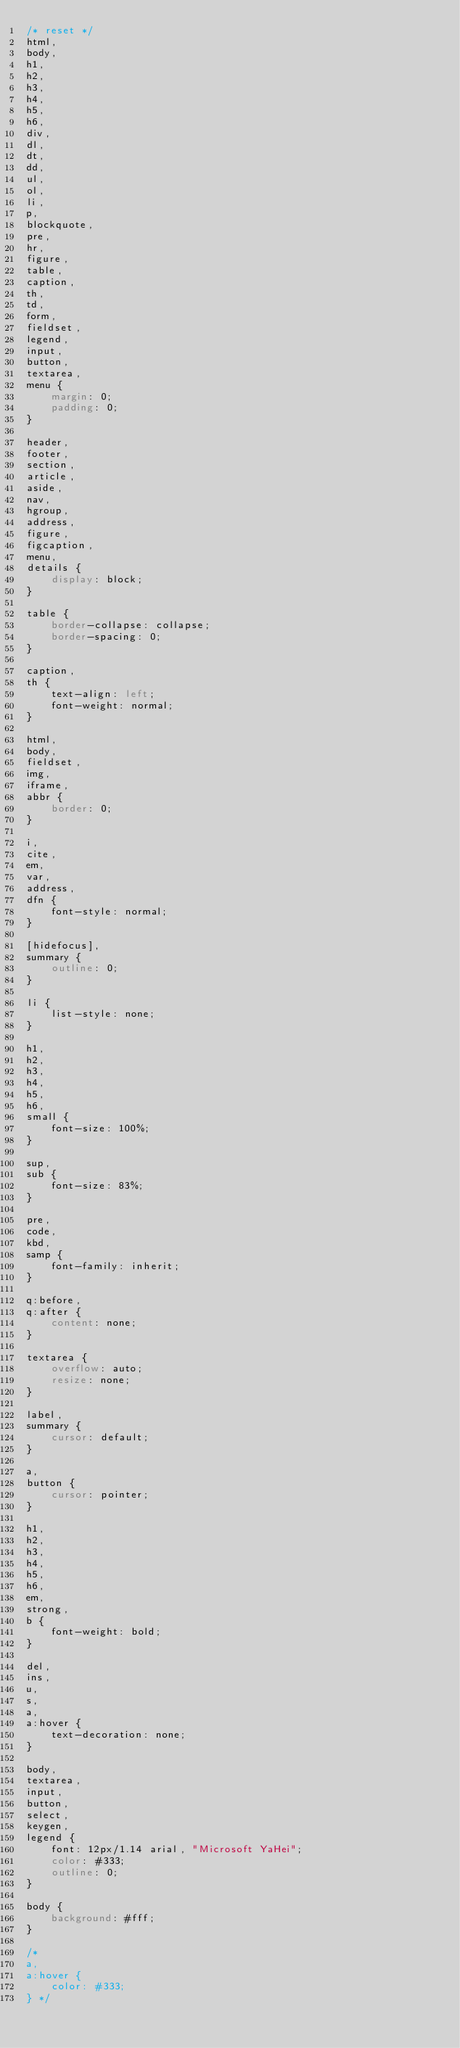Convert code to text. <code><loc_0><loc_0><loc_500><loc_500><_CSS_>/* reset */
html,
body,
h1,
h2,
h3,
h4,
h5,
h6,
div,
dl,
dt,
dd,
ul,
ol,
li,
p,
blockquote,
pre,
hr,
figure,
table,
caption,
th,
td,
form,
fieldset,
legend,
input,
button,
textarea,
menu {
    margin: 0;
    padding: 0;
}

header,
footer,
section,
article,
aside,
nav,
hgroup,
address,
figure,
figcaption,
menu,
details {
    display: block;
}

table {
    border-collapse: collapse;
    border-spacing: 0;
}

caption,
th {
    text-align: left;
    font-weight: normal;
}

html,
body,
fieldset,
img,
iframe,
abbr {
    border: 0;
}

i,
cite,
em,
var,
address,
dfn {
    font-style: normal;
}

[hidefocus],
summary {
    outline: 0;
}

li {
    list-style: none;
}

h1,
h2,
h3,
h4,
h5,
h6,
small {
    font-size: 100%;
}

sup,
sub {
    font-size: 83%;
}

pre,
code,
kbd,
samp {
    font-family: inherit;
}

q:before,
q:after {
    content: none;
}

textarea {
    overflow: auto;
    resize: none;
}

label,
summary {
    cursor: default;
}

a,
button {
    cursor: pointer;
}

h1,
h2,
h3,
h4,
h5,
h6,
em,
strong,
b {
    font-weight: bold;
}

del,
ins,
u,
s,
a,
a:hover {
    text-decoration: none;
}

body,
textarea,
input,
button,
select,
keygen,
legend {
    font: 12px/1.14 arial, "Microsoft YaHei";
    color: #333;
    outline: 0;
}

body {
    background: #fff;
}

/* 
a,
a:hover {
    color: #333;
} */</code> 